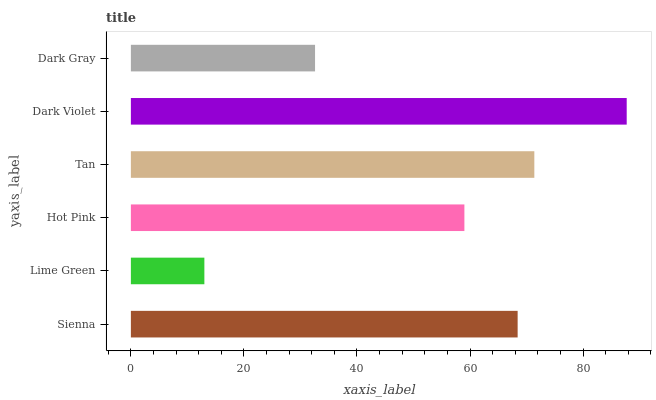Is Lime Green the minimum?
Answer yes or no. Yes. Is Dark Violet the maximum?
Answer yes or no. Yes. Is Hot Pink the minimum?
Answer yes or no. No. Is Hot Pink the maximum?
Answer yes or no. No. Is Hot Pink greater than Lime Green?
Answer yes or no. Yes. Is Lime Green less than Hot Pink?
Answer yes or no. Yes. Is Lime Green greater than Hot Pink?
Answer yes or no. No. Is Hot Pink less than Lime Green?
Answer yes or no. No. Is Sienna the high median?
Answer yes or no. Yes. Is Hot Pink the low median?
Answer yes or no. Yes. Is Hot Pink the high median?
Answer yes or no. No. Is Dark Violet the low median?
Answer yes or no. No. 